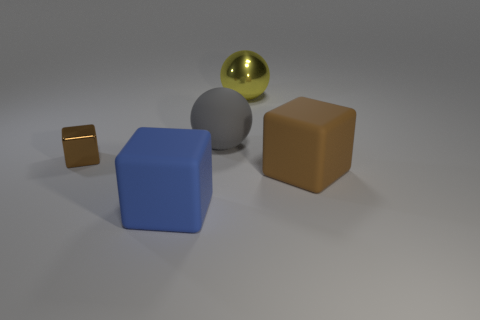Subtract all large blue cubes. How many cubes are left? 2 Subtract all blue cylinders. How many brown blocks are left? 2 Add 3 gray objects. How many objects exist? 8 Subtract all spheres. How many objects are left? 3 Subtract all blue cubes. How many cubes are left? 2 Subtract 1 balls. How many balls are left? 1 Add 5 small blocks. How many small blocks are left? 6 Add 4 big rubber blocks. How many big rubber blocks exist? 6 Subtract 0 green cylinders. How many objects are left? 5 Subtract all red balls. Subtract all cyan cubes. How many balls are left? 2 